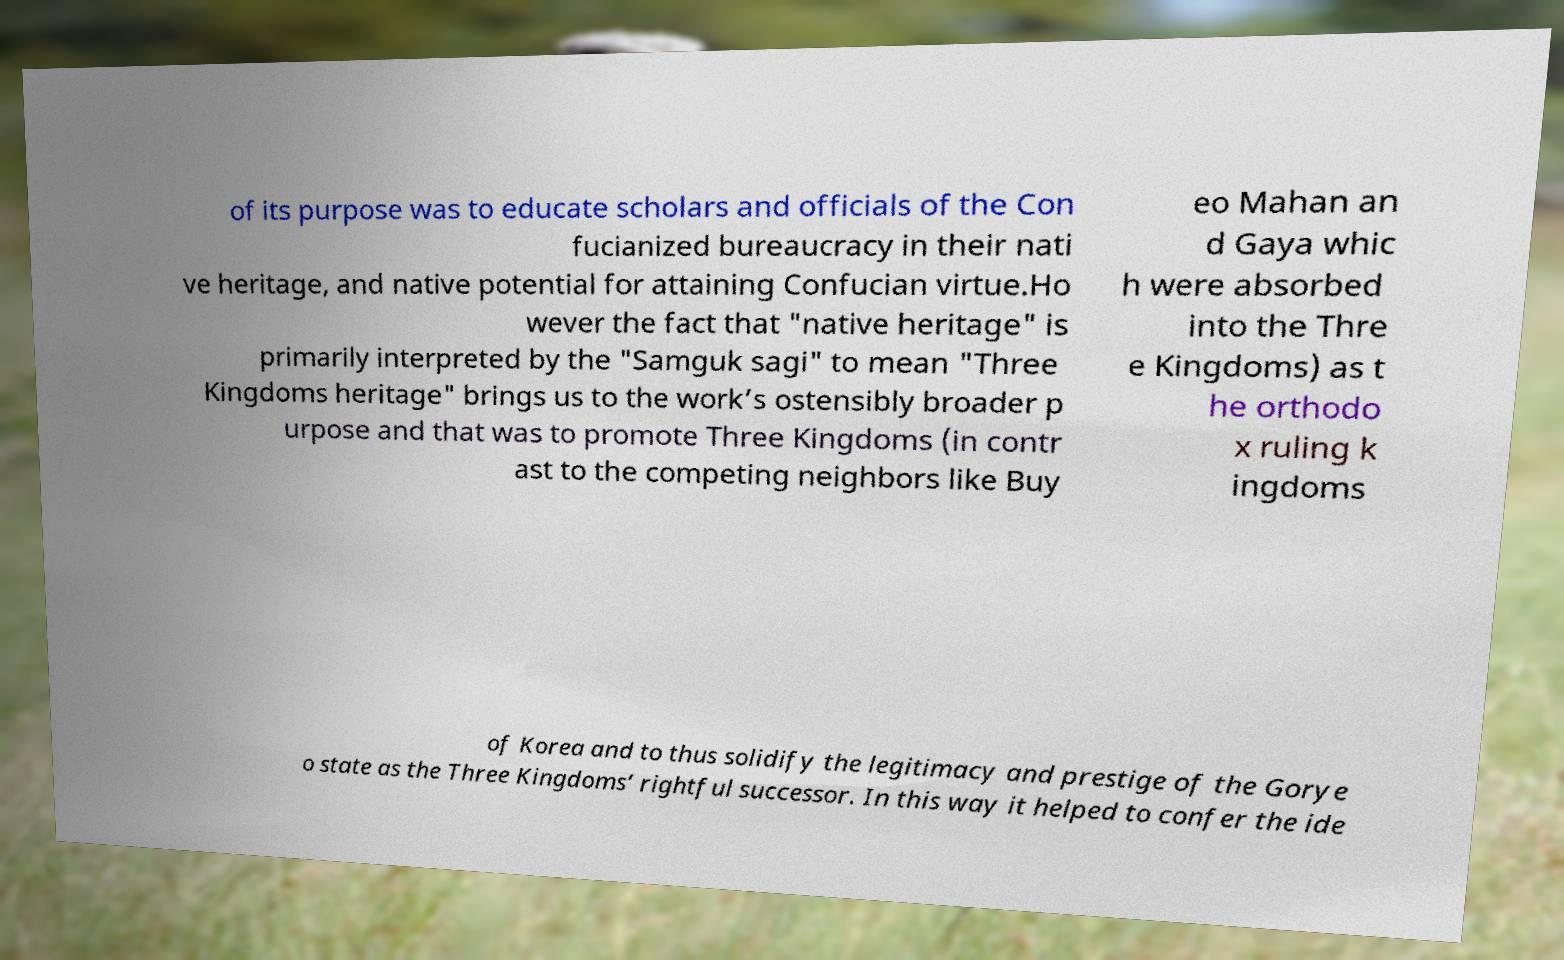Can you accurately transcribe the text from the provided image for me? of its purpose was to educate scholars and officials of the Con fucianized bureaucracy in their nati ve heritage, and native potential for attaining Confucian virtue.Ho wever the fact that "native heritage" is primarily interpreted by the "Samguk sagi" to mean "Three Kingdoms heritage" brings us to the work’s ostensibly broader p urpose and that was to promote Three Kingdoms (in contr ast to the competing neighbors like Buy eo Mahan an d Gaya whic h were absorbed into the Thre e Kingdoms) as t he orthodo x ruling k ingdoms of Korea and to thus solidify the legitimacy and prestige of the Gorye o state as the Three Kingdoms’ rightful successor. In this way it helped to confer the ide 